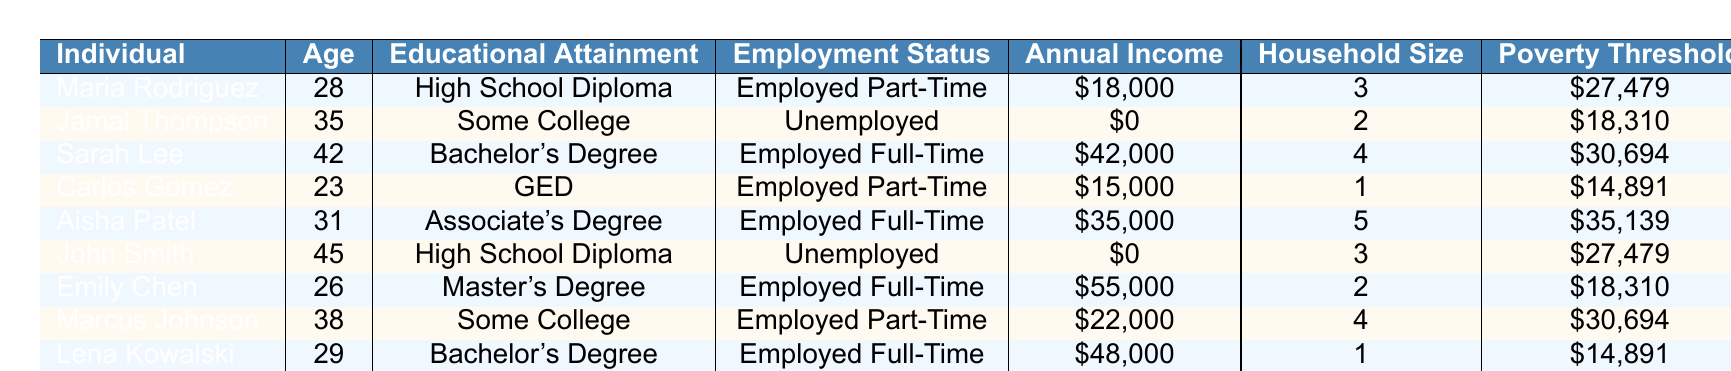What is the employment status of David Nguyen? David Nguyen is listed under the "Employment Status" column in the table, which shows he is "Employed Full-Time."
Answer: Employed Full-Time How many individuals in the table have a Bachelor’s Degree? By examining the "Educational Attainment" column, both Sarah Lee and Lena Kowalski have a Bachelor's Degree, making it a total of two individuals.
Answer: 2 What is the annual income of Emily Chen? Looking at the table, Emily Chen's entry shows she has an annual income of $55,000.
Answer: $55,000 Is there any individual in the table with an annual income above $40,000? By reviewing the "Annual Income" column, I see that both Emily Chen ($55,000) and Sarah Lee ($42,000) have incomes above $40,000. Therefore, the answer is yes.
Answer: Yes What is the average household size of individuals who are unemployed? The individuals who are unemployed are Jamal Thompson and John Smith. Their household sizes are 2 and 3, respectively, summing to 5. There are 2 unemployed individuals, so the average household size is 5/2 = 2.5.
Answer: 2.5 Which education level has the highest average income? The income across education levels is as follows: High School Diploma ($9,000), Some College ($22,000), Bachelor's Degree ($48,000), GED ($15,000), and Associate's Degree ($40,000). Summarizing: High School average is $9,000, Some College is $22,000, Bachelor's Degree is $48,000, GED is $15,000, and Associate's Degree is $40,000. The highest is the Bachelor's Degree.
Answer: Bachelor's Degree How many people are employed part-time, and what is their average annual income? From the table, Maria Rodriguez earns $18,000, Carlos Gomez earns $15,000, and Marcus Johnson earns $22,000. There are 3 people employed part-time, and their combined income is $18,000 + $15,000 + $22,000 = $55,000, resulting in an average of $55,000/3 = $18,333.33.
Answer: $18,333.33 What percentage of the individuals in the table are employed full-time? The table shows 5 individuals out of 10 are employed full-time. To find the percentage, divide 5 by 10 and multiply by 100, yielding (5/10) * 100 = 50%.
Answer: 50% Is the poverty threshold higher for individuals with a GED than for those with a high school diploma? The poverty threshold for Carlos Gomez (GED) is $14,891 and for both Maria Rodriguez and John Smith (high school diploma) is $27,479. Since $14,891 is not higher than $27,479, the answer is no.
Answer: No Which individual has the lowest annual income and what is that income? Looking through the "Annual Income" column, Jamal Thompson has an income of $0, which is the lowest among all individuals listed.
Answer: $0 